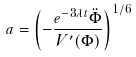Convert formula to latex. <formula><loc_0><loc_0><loc_500><loc_500>a = \left ( - \frac { e ^ { - 3 \lambda t } \ddot { \Phi } } { V ^ { \prime } ( \Phi ) } \right ) ^ { 1 / 6 }</formula> 